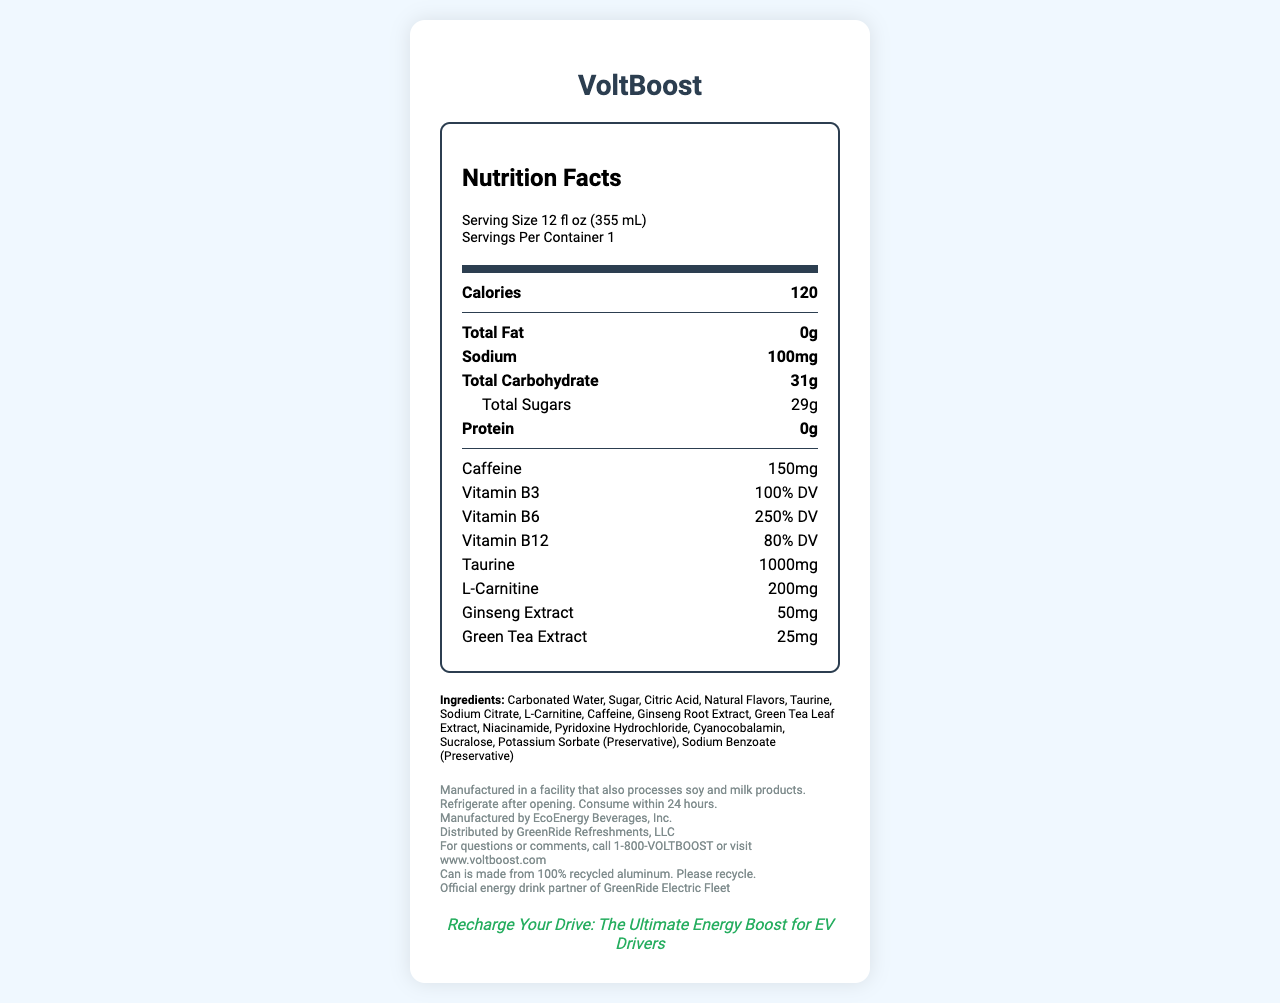what is the serving size of VoltBoost? The serving size is listed under the "Serving Size" section on the nutrition label.
Answer: 12 fl oz (355 mL) How many calories does one serving of VoltBoost contain? The calorie content is listed in the "Calories" section on the nutrition label.
Answer: 120 What is the total carbohydrate content in VoltBoost? The total carbohydrate content is listed in the "Total Carbohydrate" section on the nutrition label.
Answer: 31g Does VoltBoost contain any protein? The "Protein" section on the nutrition label shows 0g, indicating there is no protein in VoltBoost.
Answer: No How much sodium is in a serving of VoltBoost? The sodium content is listed in the "Sodium" section on the nutrition label.
Answer: 100mg Which of the following vitamins is present at 250% DV in VoltBoost? A. Vitamin B3 B. Vitamin B6 C. Vitamin B12 Vitamin B6 is listed with a value of 250% DV on the nutrition label.
Answer: B What is the primary purpose of taurine in energy drinks like VoltBoost? (Choose the most accurate) i. Energy boost ii. Flavoring agent iii. Preservative Taurine is commonly added to energy drinks for its potential to boost energy and mental performance.
Answer: i How much caffeine does VoltBoost contain? The caffeine content is listed in the "Caffeine" section on the nutrition label.
Answer: 150mg Is VoltBoost manufactured in a facility that processes soy and milk products? The allergen information indicates that VoltBoost is manufactured in a facility that also processes soy and milk products.
Answer: Yes What is the tagline used for marketing VoltBoost? The marketing tagline is shown towards the bottom of the document.
Answer: Recharge Your Drive: The Ultimate Energy Boost for EV Drivers Summarize the main idea of the VoltBoost Nutrition Facts Label. The nutrition facts label provides detailed information on the contents and nutritional value of VoltBoost, highlighting its key ingredients and manufacturing information, along with sustainability and safety notes.
Answer: VoltBoost is an energy drink designed for electric vehicle drivers, containing 120 calories per serving with 0g of fat, 100mg of sodium, 31g of carbohydrates, and 0g of protein. It includes 150mg of caffeine and a blend of vitamins and ingredients such as taurine, L-carnitine, ginseng extract, and green tea extract. It is manufactured by EcoEnergy Beverages, Inc. and distributed by GreenRide Refreshments, LLC. Special notes include being produced in a facility that processes soy and milk and having recyclable packaging. What is the quantity of taurine found in VoltBoost? The taurine content is listed in the "Taurine" section on the nutrition label.
Answer: 1000mg Can you determine whether VoltBoost contains artificial sweeteners from the document? The list of ingredients includes Sucralose, which is an artificial sweetener.
Answer: Yes Who manufactures VoltBoost? The footer information of the document states that VoltBoost is manufactured by EcoEnergy Beverages, Inc.
Answer: EcoEnergy Beverages, Inc. What is the sodium preservative used in VoltBoost? The list of ingredients includes Sodium Benzoate as a preservative.
Answer: Sodium Benzoate Does VoltBoost need to be refrigerated after opening? The storage instructions at the bottom of the document indicate that VoltBoost should be refrigerated after opening.
Answer: Yes Can the exact formula or recipe of VoltBoost be determined from the document? The document provides the list of ingredients but not the exact amounts or formula used in the preparation of VoltBoost.
Answer: No 